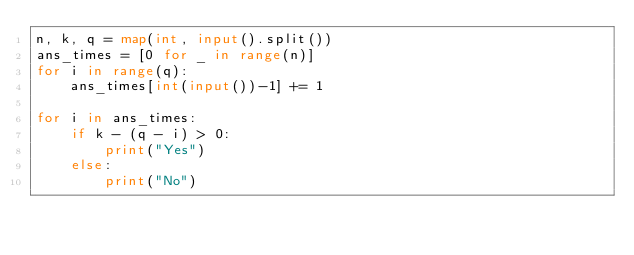<code> <loc_0><loc_0><loc_500><loc_500><_Python_>n, k, q = map(int, input().split())
ans_times = [0 for _ in range(n)]
for i in range(q):
    ans_times[int(input())-1] += 1

for i in ans_times:
    if k - (q - i) > 0:
        print("Yes")
    else:
        print("No")</code> 